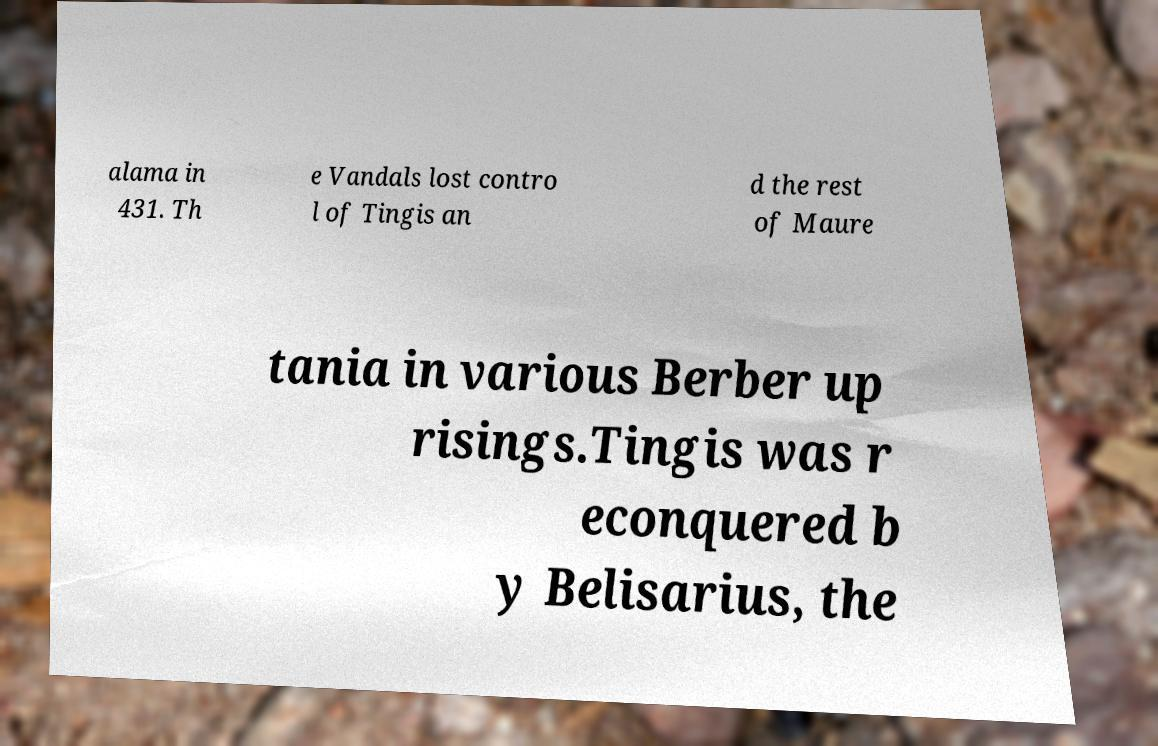Please read and relay the text visible in this image. What does it say? alama in 431. Th e Vandals lost contro l of Tingis an d the rest of Maure tania in various Berber up risings.Tingis was r econquered b y Belisarius, the 